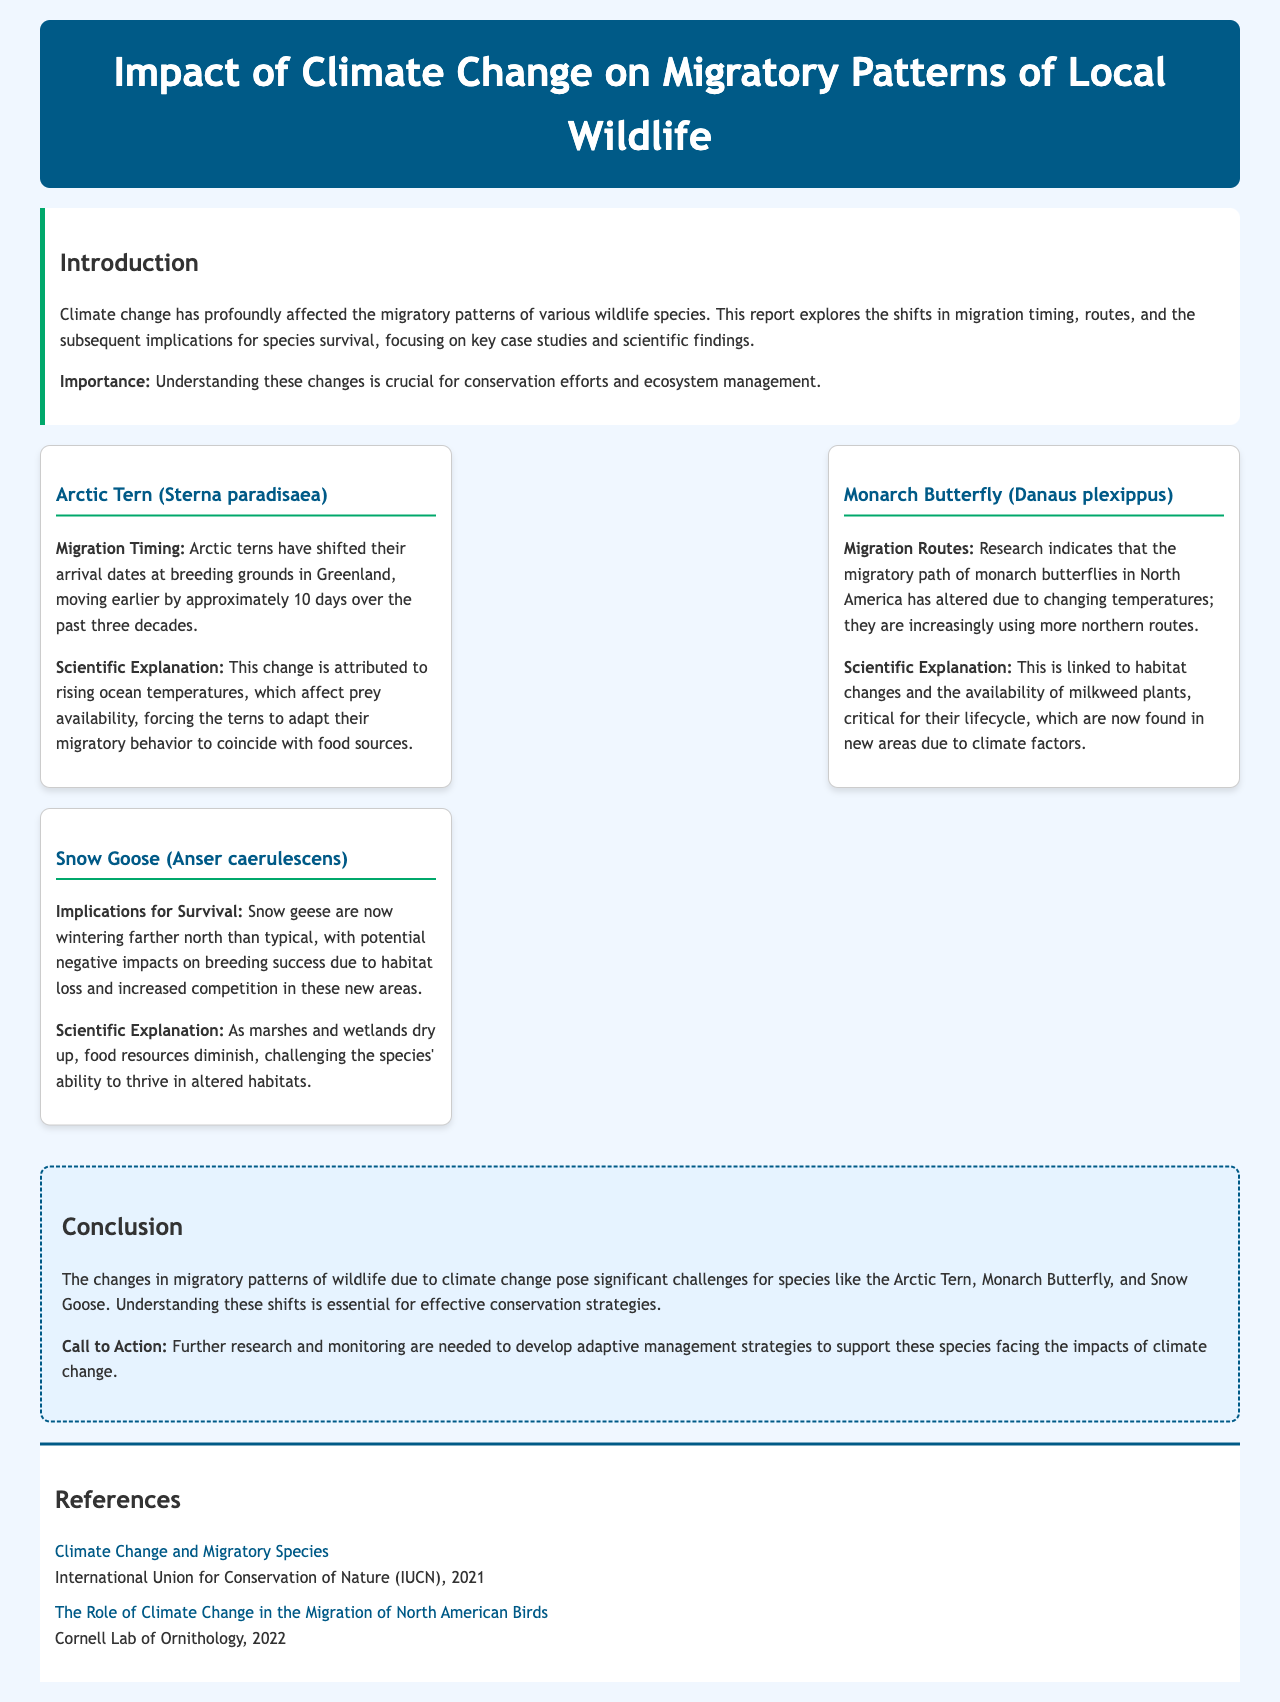what species is being studied for migration timing changes? The report focuses on the Arctic Tern, which has shifted its arrival dates at breeding grounds.
Answer: Arctic Tern how many days earlier have Arctic terns shifted their arrival dates? The document states that Arctic terns have shifted their arrival dates earlier by approximately 10 days over the past three decades.
Answer: 10 days what is affecting the migration routes of Monarch Butterflies? The migratory path of Monarch Butterflies is altered due to changing temperatures and habitat changes affecting milkweed availability.
Answer: Changing temperatures what is the scientific explanation for Snow Geese wintering farther north? The negative impacts on Snow Goose breeding success are linked to habitat loss and increased competition in new areas.
Answer: Habitat loss what crucial aspect is needed for conservation efforts mentioned in the conclusion? Understanding the shifts in migratory patterns is deemed essential for effective conservation strategies.
Answer: Understanding shifts what organization published information regarding climate change and migratory species? The International Union for Conservation of Nature published a report on this topic in 2021.
Answer: International Union for Conservation of Nature 